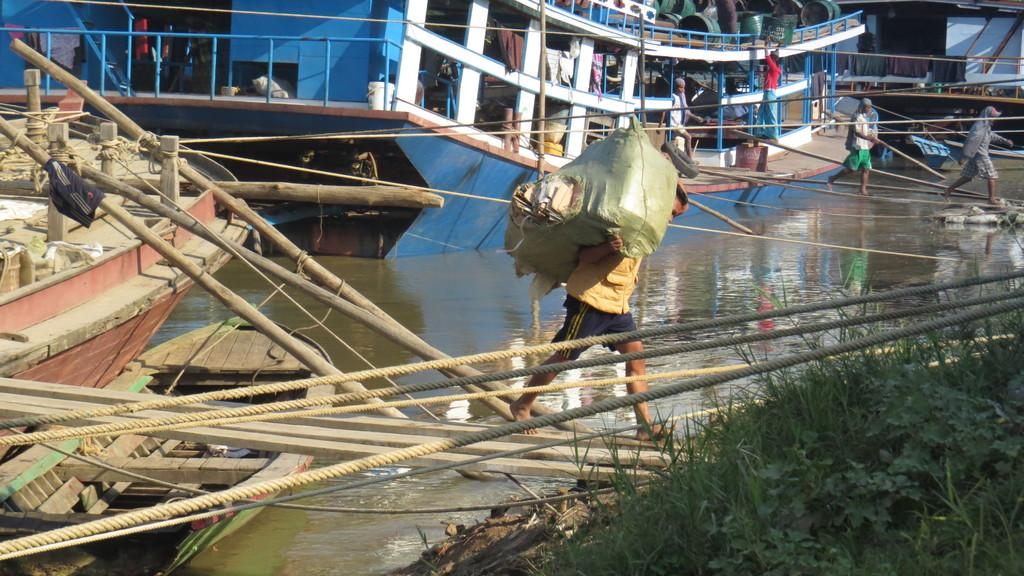What can be seen in the image that is used for transportation on water? There are boats in the image that are used for transportation on water. Where are the boats located in the image? The boats are on a river in the image. What are the ropes used for in the image? The ropes are not explicitly described in the facts, but they could be used for mooring the boats or for other purposes related to the boats or the river. What type of surface are the people walking on in the image? The people are walking on wooden planks in the image. Are there any rabbits playing with balls in the snow in the image? There is no mention of snow, rabbits, or balls in the image. The image features boats on a river, ropes, and people walking on wooden planks. 